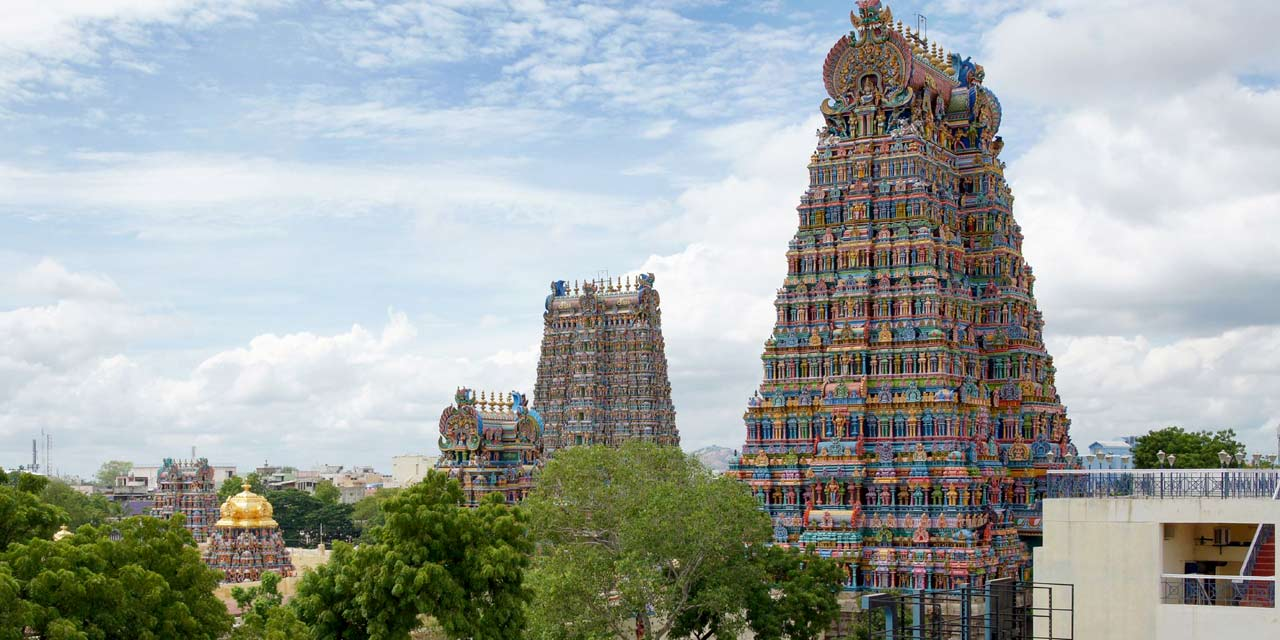If this temple could speak, what stories would it tell? If the Meenakshi Amman Temple could speak, it would recount tales of ancient traditions, of the divine love story between Meenakshi and Sundareswarar, and of the countless devotees who have walked its corridors seeking blessings over centuries. It would narrate the legends immortalized in its sculptures, the dynasties that contributed to its construction, and the festivals that have filled its halls with music, dance, and prayers. The temple would share the story of its evolution through history, surviving invasions and natural calamities, yet standing resilient as a beacon of faith and culture. It would tell of the artisans who infused their souls into every statue and carving, and of the vibrant life that pulses within it to this day, as a sacred space of worship, celebration, and preservation of Tamil heritage. What do you think the temple sees as it stands tall over the city? From its towering heights, the Meenakshi Amman Temple witnesses a bustling cityscape of Madurai unfolding beneath it. It sees the faithful coming for their daily prayers, the vibrant throngs of people during festive times, and the tranquil moments of dawn and dusk when the city is bathed in a golden hue. It watches the ebb and flow of life, the blend of ancient tradition with modernity, and the seamless integration of commerce, culture, and spirituality in the city's rhythm. Trees whispering secrets with the winds, the changing seasons painting different moods, and the sounds of chants mingling with modern urban noises – the temple stands as a timeless sentinel, observing the perpetual dance of life around it. 